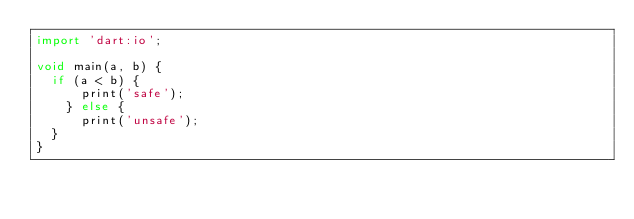<code> <loc_0><loc_0><loc_500><loc_500><_Dart_>import 'dart:io';

void main(a, b) {
	if (a < b) {
    	print('safe');
    } else {
    	print('unsafe');
	}
}
</code> 